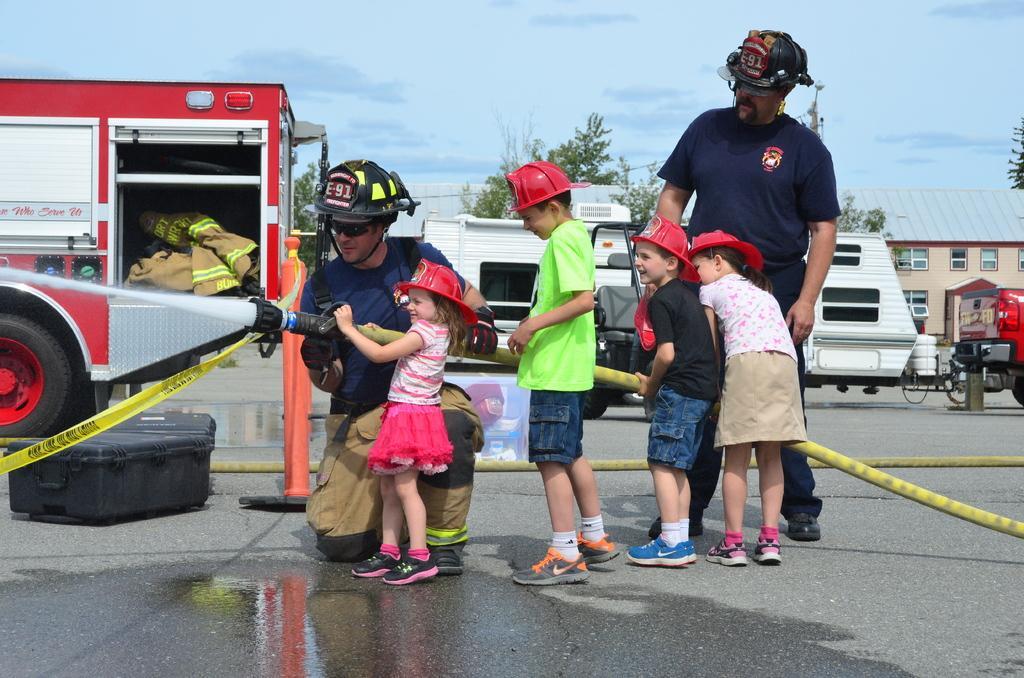Could you give a brief overview of what you see in this image? This picture is clicked on the road. There are two men and four kids standing on the road. Behind them there are vehicles. In the background there are houses and trees. At the top there is the sky. To the left there is a box on the road. They all are wearing helmets. 